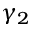<formula> <loc_0><loc_0><loc_500><loc_500>\gamma _ { 2 }</formula> 